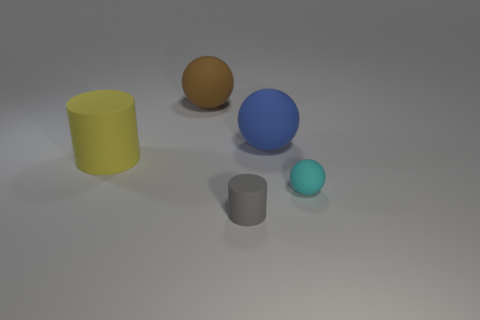Is there any other thing of the same color as the large cylinder?
Provide a short and direct response. No. What is the shape of the matte thing to the left of the ball that is behind the large object that is right of the tiny matte cylinder?
Your answer should be very brief. Cylinder. There is a large thing that is the same shape as the tiny gray rubber object; what is its color?
Your answer should be compact. Yellow. There is a small matte object that is left of the small matte thing that is on the right side of the gray cylinder; what is its color?
Keep it short and to the point. Gray. What size is the blue thing that is the same shape as the small cyan matte object?
Your answer should be very brief. Large. How many small gray cylinders have the same material as the brown object?
Your answer should be compact. 1. What number of cyan rubber things are on the left side of the small rubber thing in front of the cyan ball?
Provide a short and direct response. 0. There is a large cylinder; are there any rubber spheres in front of it?
Your answer should be compact. Yes. There is a object that is in front of the tiny cyan thing; is its shape the same as the yellow rubber object?
Your answer should be very brief. Yes. How many other rubber spheres have the same color as the small sphere?
Your answer should be very brief. 0. 